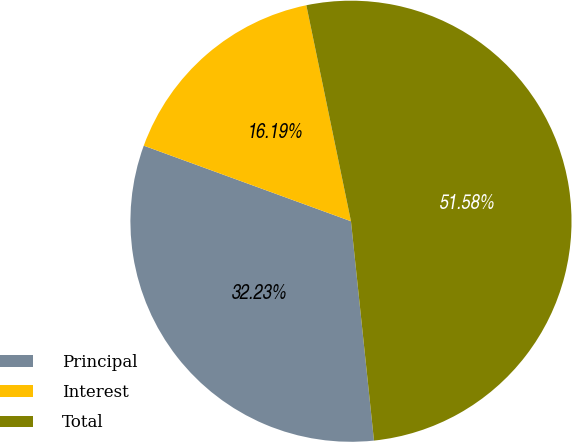<chart> <loc_0><loc_0><loc_500><loc_500><pie_chart><fcel>Principal<fcel>Interest<fcel>Total<nl><fcel>32.23%<fcel>16.19%<fcel>51.58%<nl></chart> 